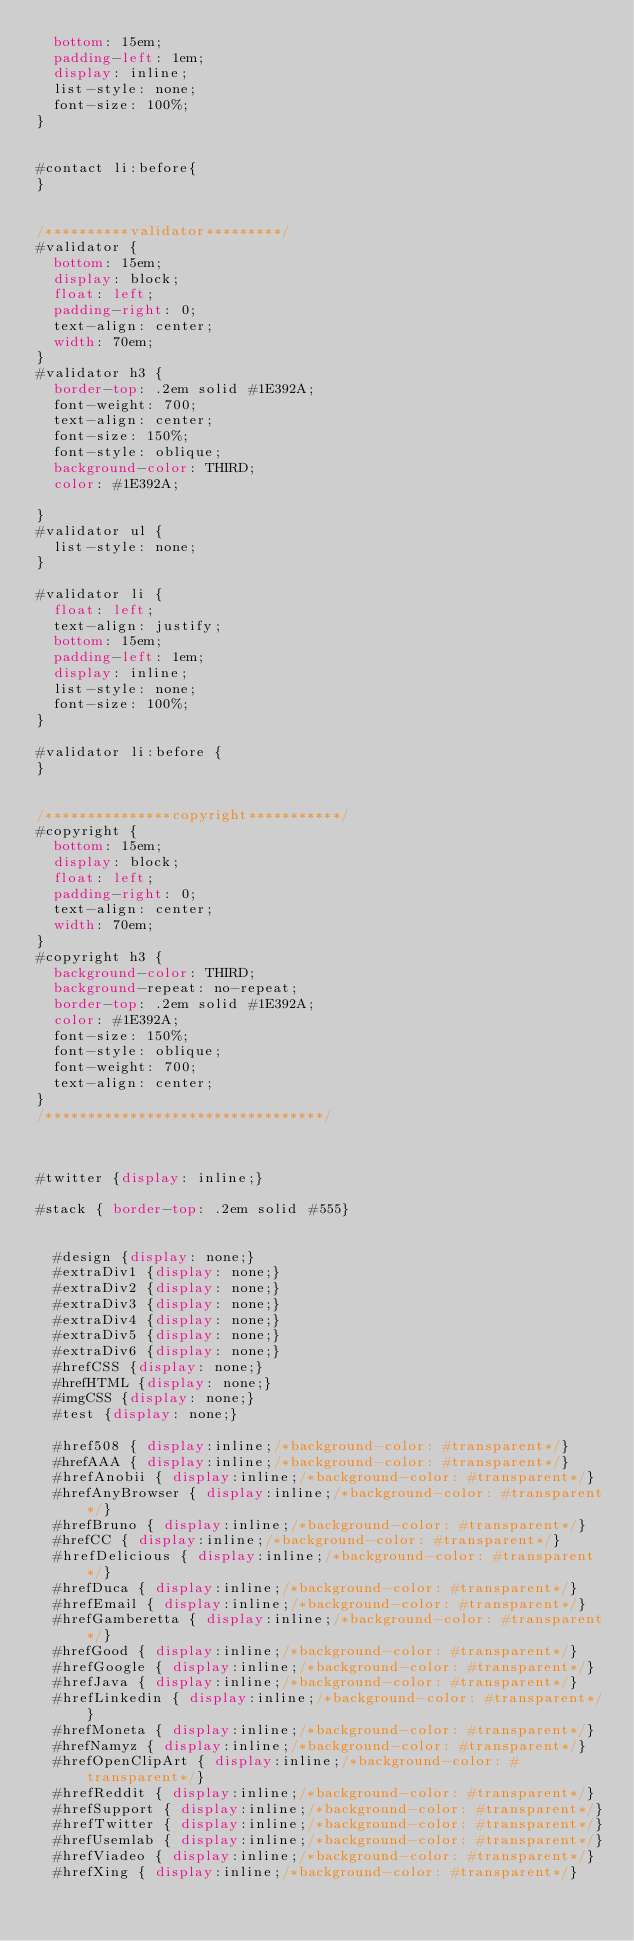<code> <loc_0><loc_0><loc_500><loc_500><_CSS_>  bottom: 15em;
  padding-left: 1em;
  display: inline;
  list-style: none;
  font-size: 100%;
}


#contact li:before{
}


/**********validator*********/
#validator {
  bottom: 15em;
  display: block;
  float: left;
  padding-right: 0;
  text-align: center;
  width: 70em;
}
#validator h3 {
  border-top: .2em solid #1E392A;
  font-weight: 700;
  text-align: center;
  font-size: 150%;
  font-style: oblique;
  background-color: THIRD;
  color: #1E392A;

}
#validator ul {
	list-style: none;
}

#validator li {
	float: left;
	text-align: justify;
	bottom: 15em;
	padding-left: 1em;
	display: inline;
	list-style: none;
	font-size: 100%;
}

#validator li:before {
}


/***************copyright***********/
#copyright {
  bottom: 15em;
  display: block;
  float: left;
  padding-right: 0;
  text-align: center;
  width: 70em;
}
#copyright h3 {
  background-color: THIRD;
  background-repeat: no-repeat;
  border-top: .2em solid #1E392A;
  color: #1E392A;
  font-size: 150%;
  font-style: oblique;
  font-weight: 700;
  text-align: center;
}
/*********************************/



#twitter {display: inline;}

#stack { border-top: .2em solid #555}


  #design {display: none;}
  #extraDiv1 {display: none;}
  #extraDiv2 {display: none;}
  #extraDiv3 {display: none;}
  #extraDiv4 {display: none;}
  #extraDiv5 {display: none;}
  #extraDiv6 {display: none;}
  #hrefCSS {display: none;}
  #hrefHTML {display: none;}
  #imgCSS {display: none;}
  #test {display: none;}

  #href508 { display:inline;/*background-color: #transparent*/}
  #hrefAAA { display:inline;/*background-color: #transparent*/}
  #hrefAnobii { display:inline;/*background-color: #transparent*/}
  #hrefAnyBrowser { display:inline;/*background-color: #transparent*/}
  #hrefBruno { display:inline;/*background-color: #transparent*/}
  #hrefCC { display:inline;/*background-color: #transparent*/}
  #hrefDelicious { display:inline;/*background-color: #transparent*/}
  #hrefDuca { display:inline;/*background-color: #transparent*/}
  #hrefEmail { display:inline;/*background-color: #transparent*/}
  #hrefGamberetta { display:inline;/*background-color: #transparent*/}
  #hrefGood { display:inline;/*background-color: #transparent*/}
  #hrefGoogle { display:inline;/*background-color: #transparent*/}
  #hrefJava { display:inline;/*background-color: #transparent*/}
  #hrefLinkedin { display:inline;/*background-color: #transparent*/}
  #hrefMoneta { display:inline;/*background-color: #transparent*/}
  #hrefNamyz { display:inline;/*background-color: #transparent*/}
  #hrefOpenClipArt { display:inline;/*background-color: #transparent*/}
  #hrefReddit { display:inline;/*background-color: #transparent*/}
  #hrefSupport { display:inline;/*background-color: #transparent*/}
  #hrefTwitter { display:inline;/*background-color: #transparent*/}
  #hrefUsemlab { display:inline;/*background-color: #transparent*/}
  #hrefViadeo { display:inline;/*background-color: #transparent*/}
  #hrefXing { display:inline;/*background-color: #transparent*/}
</code> 